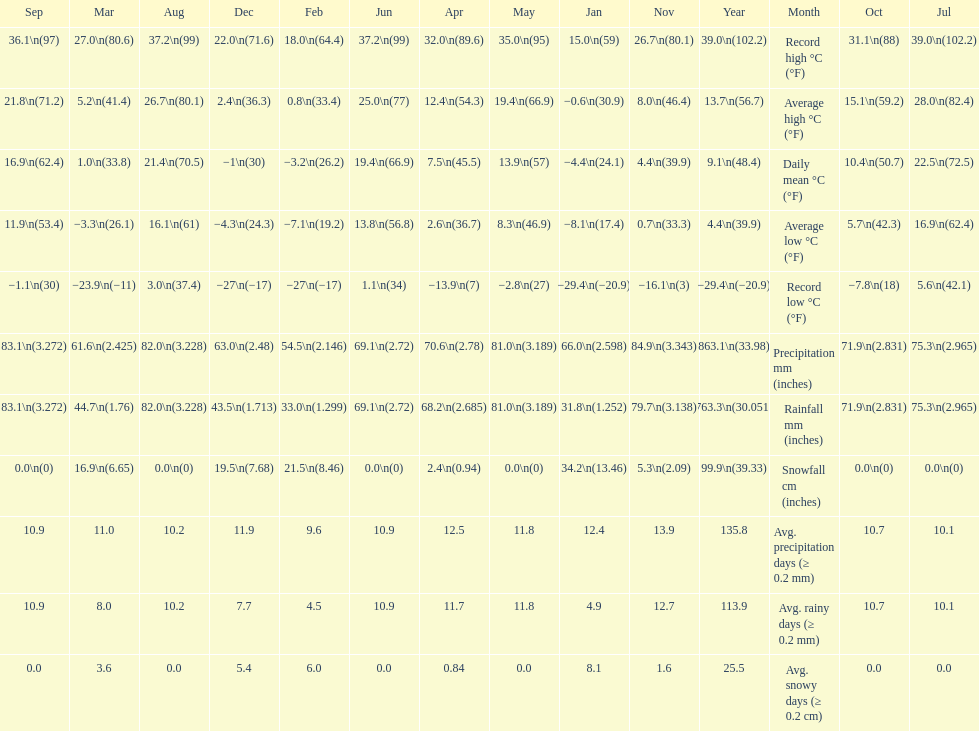Which month had an average high of 21.8 degrees and a record low of -1.1? September. 